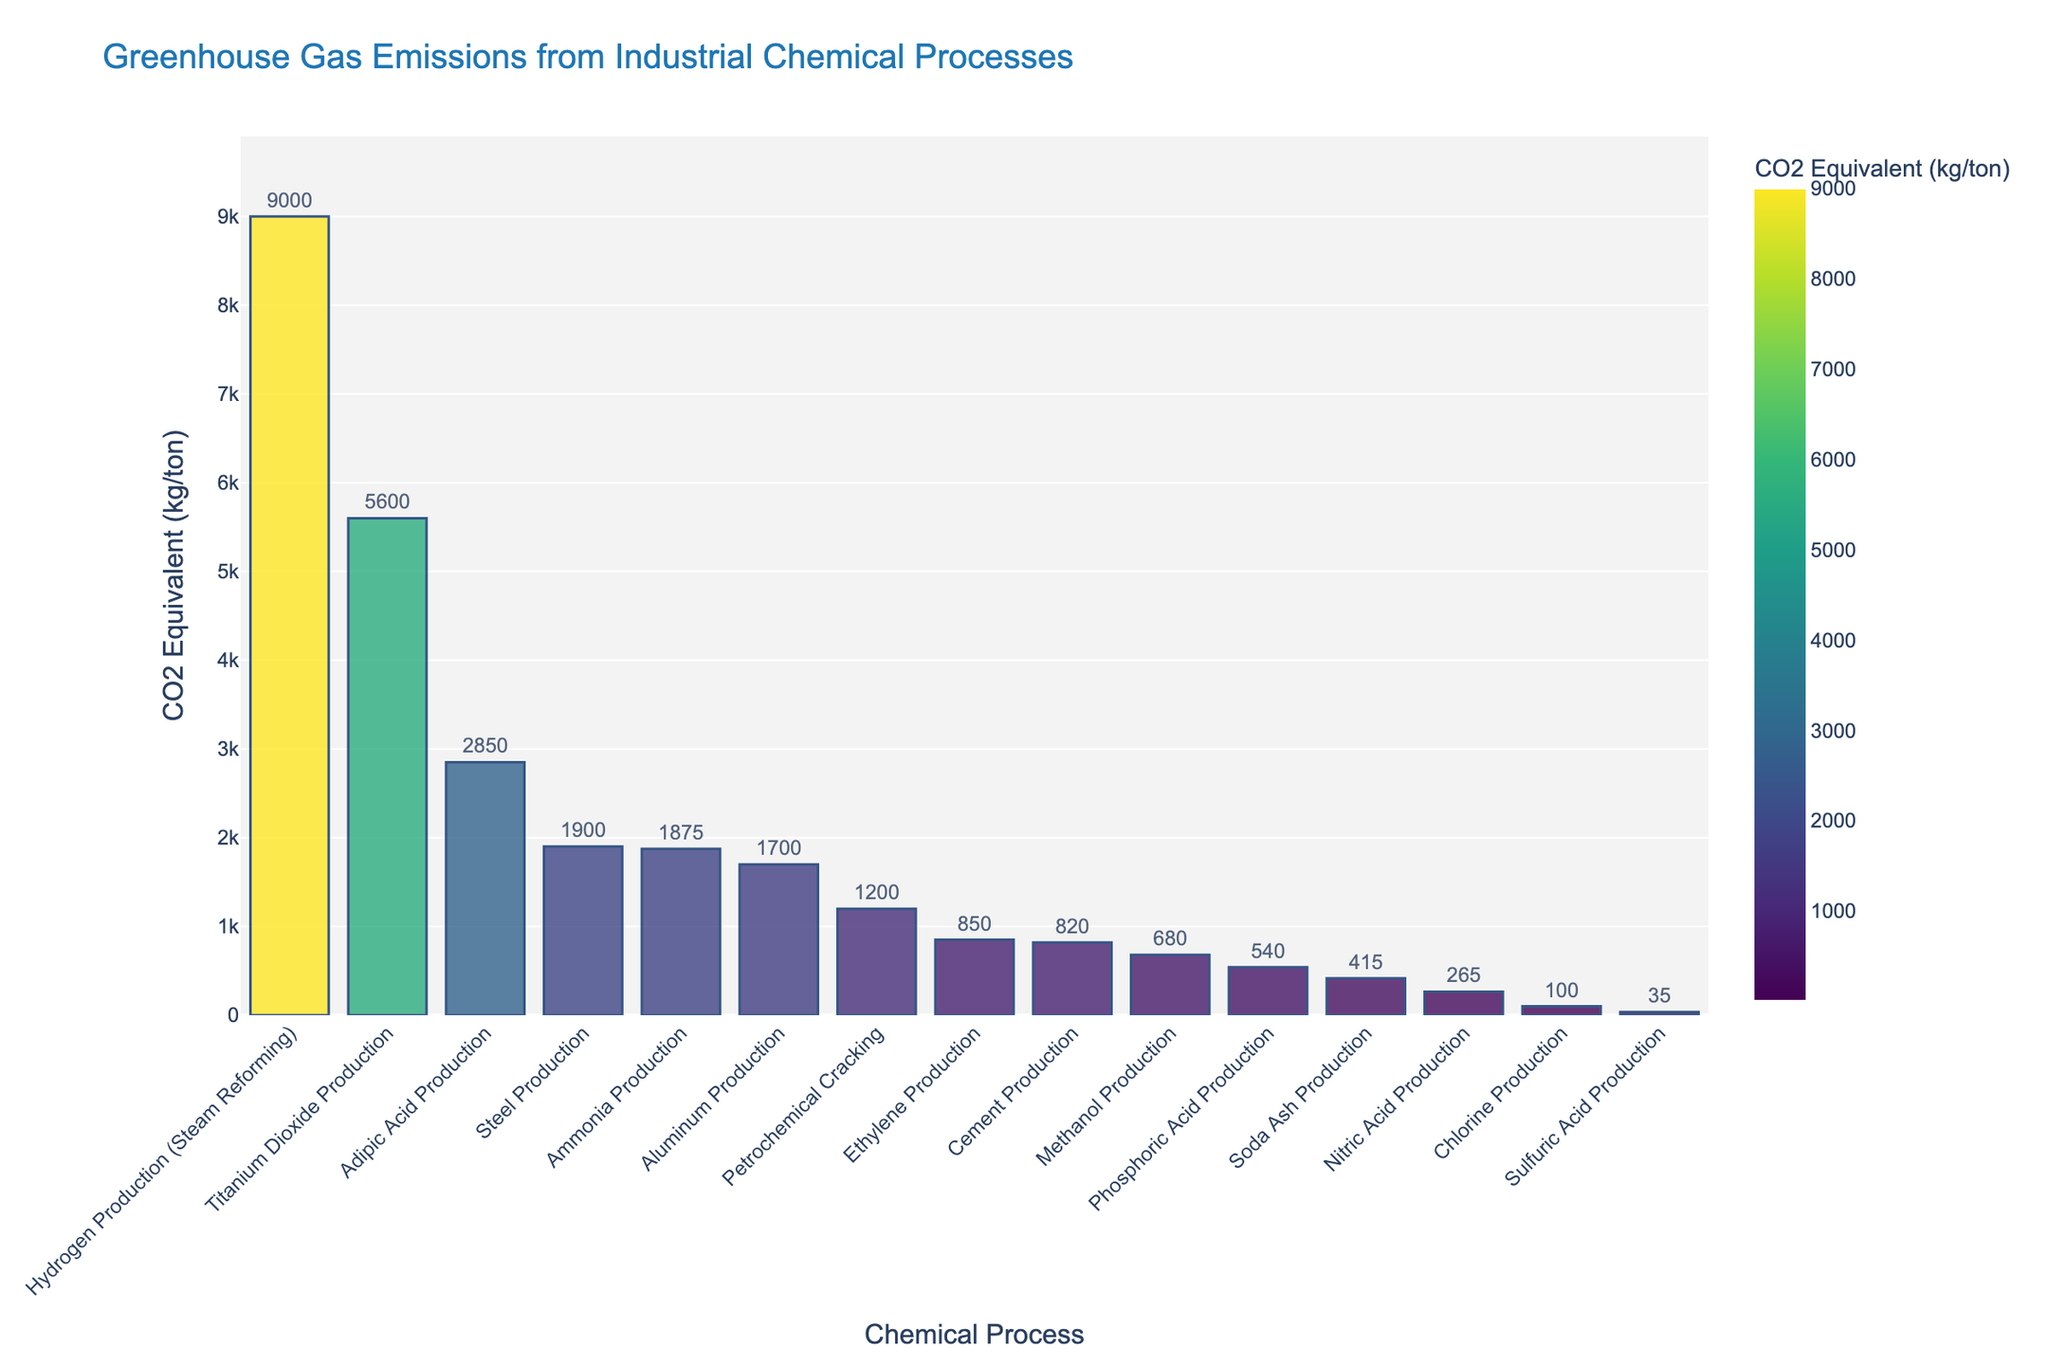Which industrial chemical process has the highest CO2 equivalent emissions? The bar for "Hydrogen Production (Steam Reforming)" is the tallest, indicating it has the highest CO2 equivalent emissions.
Answer: Hydrogen Production (Steam Reforming) How much more CO2 is emitted from steel production compared to cement production? Steel Production has a CO2 equivalent emission of 1900 kg/ton, and Cement Production has 820 kg/ton. The difference is 1900 - 820 = 1080.
Answer: 1080 kg/ton Which two processes have the closest CO2 equivalent emissions and what are these values? By visually comparing the heights of the bars, Methanol Production and Phosphoric Acid Production have very close values, which are 680 kg/ton and 540 kg/ton respectively.
Answer: Methanol Production (680 kg/ton) and Phosphoric Acid Production (540 kg/ton) Which processes emit less than 1000 kg/ton of CO2 equivalent? By looking at the bars shorter than the 1000 kg/ton mark: Chlorine Production, Sulfuric Acid Production, Methanol Production, Phosphoric Acid Production, Nitric Acid Production, Adipic Acid Production, Cement Production, and Soda Ash Production emit less than 1000 kg/ton.
Answer: Chlorine Production, Sulfuric Acid Production, Methanol Production, Phosphoric Acid Production, Nitric Acid Production, Adipic Acid Production, Cement Production, Soda Ash Production What is the combined total CO2 equivalent emissions of Adipic Acid Production, Steel Production, and Aluminum Production? The emissions are Adipic Acid Production: 2850, Steel Production: 1900, and Aluminum Production: 1700. Summing these: 2850 + 1900 + 1700 = 6450 kg/ton.
Answer: 6450 kg/ton How many times higher is CO2 emission from Hydrogen Production compared to Soda Ash Production? Hydrogen Production emits 9000 kg/ton, and Soda Ash Production emits 415 kg/ton. The ratio is 9000 / 415 = 21.69, approximately 22 times.
Answer: ~22 times Which process has the least CO2 equivalent emissions and what is that value? The shortest bar is for Sulfuric Acid Production, indicating the least CO2 equivalent emissions at 35 kg/ton.
Answer: Sulfuric Acid Production (35 kg/ton) What is the difference in CO2 emissions between the highest and the lowest emitting processes? Hydrogen Production emits 9000 kg/ton and Sulfuric Acid Production emits 35 kg/ton. The difference is 9000 - 35 = 8965 kg/ton.
Answer: 8965 kg/ton Arrange the top three processes with the highest CO2 emissions in descending order. By reviewing the heights of the bars, Hydrogen Production, Titanium Dioxide Production, and Adipic Acid Production emit the most CO2 in descending order.
Answer: Hydrogen Production, Titanium Dioxide Production, Adipic Acid Production If the process emitting the second highest CO2 equivalent (Titanium Dioxide Production) were reduced by 50%, what would be the new emission value? Titanium Dioxide Production emits 5600 kg/ton. Reducing it by 50%: 5600 * 0.5 = 2800 kg/ton.
Answer: 2800 kg/ton 